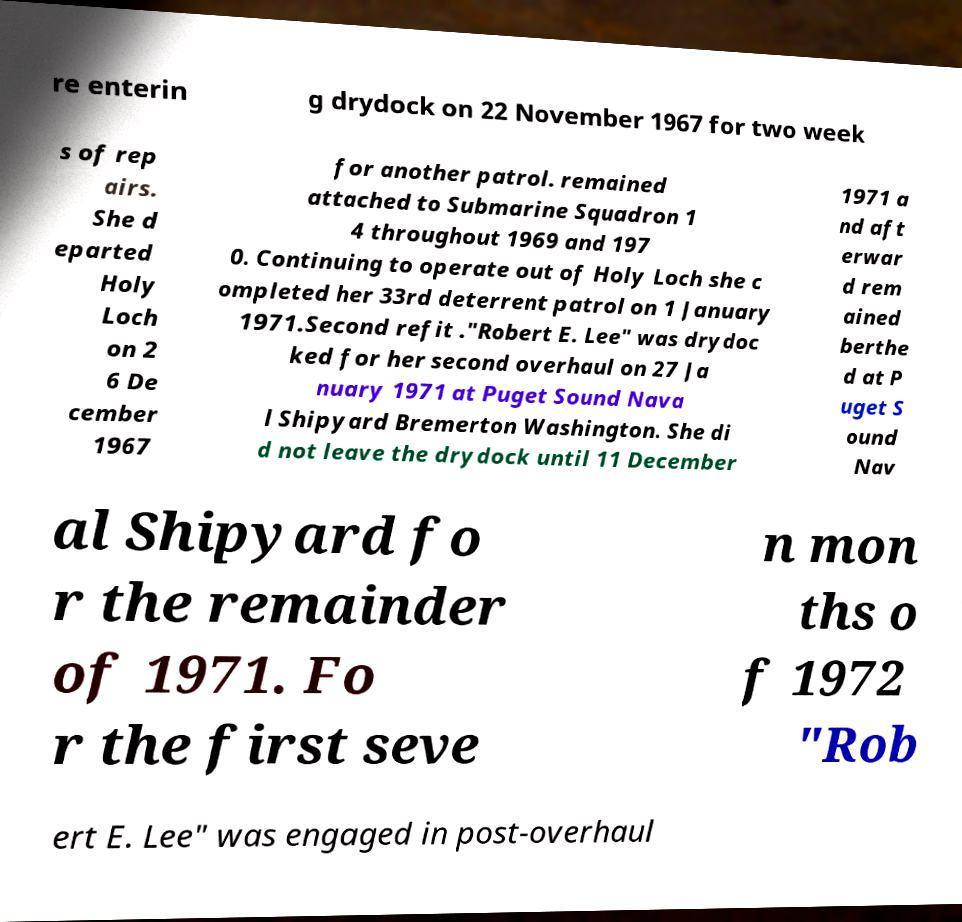Could you assist in decoding the text presented in this image and type it out clearly? re enterin g drydock on 22 November 1967 for two week s of rep airs. She d eparted Holy Loch on 2 6 De cember 1967 for another patrol. remained attached to Submarine Squadron 1 4 throughout 1969 and 197 0. Continuing to operate out of Holy Loch she c ompleted her 33rd deterrent patrol on 1 January 1971.Second refit ."Robert E. Lee" was drydoc ked for her second overhaul on 27 Ja nuary 1971 at Puget Sound Nava l Shipyard Bremerton Washington. She di d not leave the drydock until 11 December 1971 a nd aft erwar d rem ained berthe d at P uget S ound Nav al Shipyard fo r the remainder of 1971. Fo r the first seve n mon ths o f 1972 "Rob ert E. Lee" was engaged in post-overhaul 